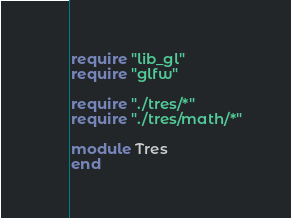Convert code to text. <code><loc_0><loc_0><loc_500><loc_500><_Crystal_>require "lib_gl"
require "glfw"

require "./tres/*"
require "./tres/math/*"

module Tres
end
</code> 